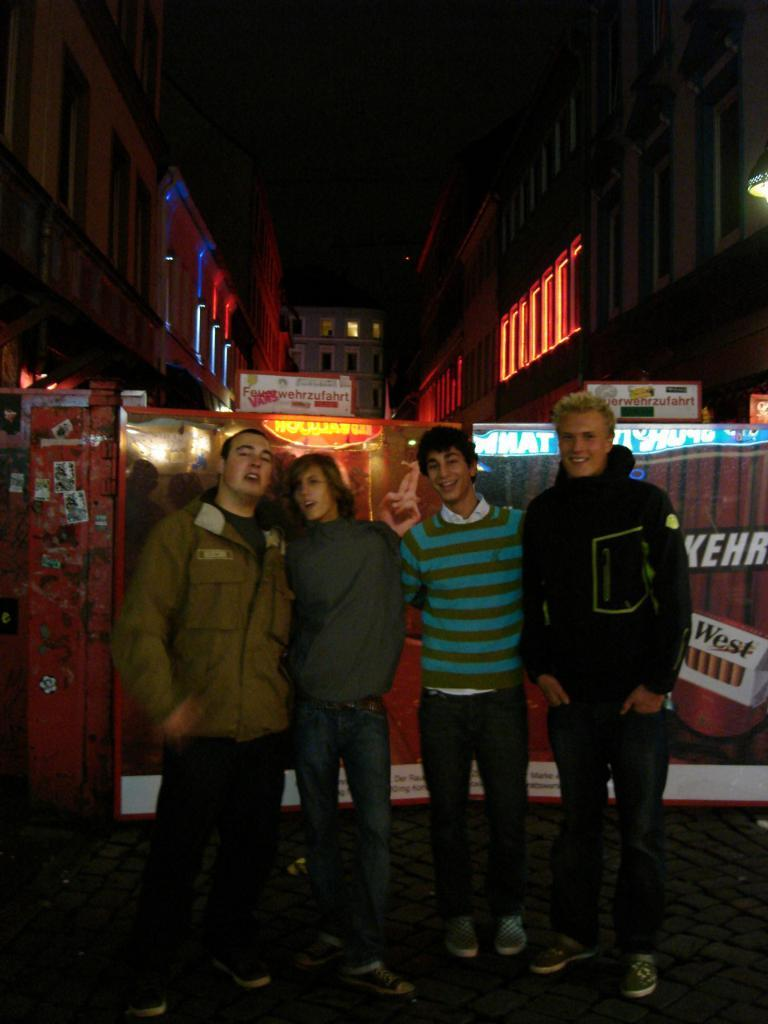How many people are in the image? There are four people in the image. What are the people doing in the image? The people are standing and smiling. What is behind the people in the image? There is a board behind the people. What can be seen in the background of the image? There are buildings with windows and lights in the image. What type of degree is the girl holding in the image? There is no girl or degree present in the image. What kind of beast can be seen roaming in the background of the image? There are no beasts present in the image; it features four people standing and smiling, a board behind them, and buildings with windows and lights in the background. 